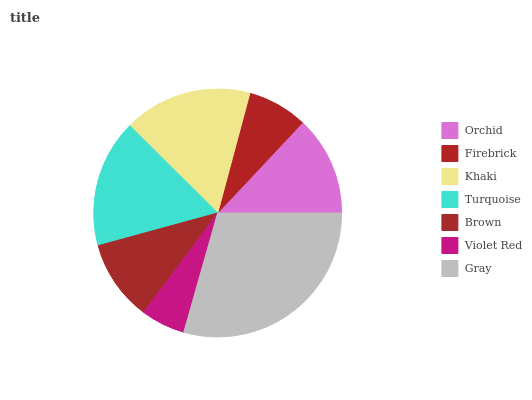Is Violet Red the minimum?
Answer yes or no. Yes. Is Gray the maximum?
Answer yes or no. Yes. Is Firebrick the minimum?
Answer yes or no. No. Is Firebrick the maximum?
Answer yes or no. No. Is Orchid greater than Firebrick?
Answer yes or no. Yes. Is Firebrick less than Orchid?
Answer yes or no. Yes. Is Firebrick greater than Orchid?
Answer yes or no. No. Is Orchid less than Firebrick?
Answer yes or no. No. Is Orchid the high median?
Answer yes or no. Yes. Is Orchid the low median?
Answer yes or no. Yes. Is Violet Red the high median?
Answer yes or no. No. Is Violet Red the low median?
Answer yes or no. No. 